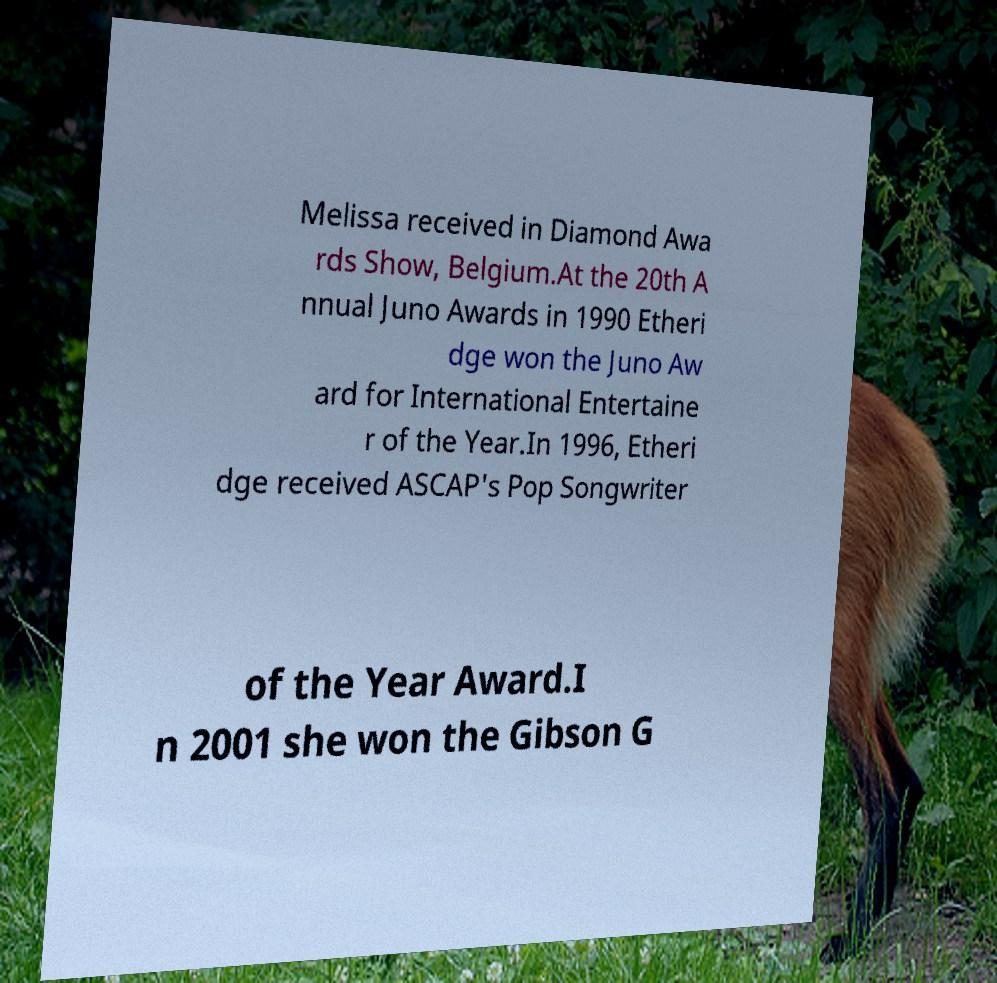What messages or text are displayed in this image? I need them in a readable, typed format. Melissa received in Diamond Awa rds Show, Belgium.At the 20th A nnual Juno Awards in 1990 Etheri dge won the Juno Aw ard for International Entertaine r of the Year.In 1996, Etheri dge received ASCAP's Pop Songwriter of the Year Award.I n 2001 she won the Gibson G 